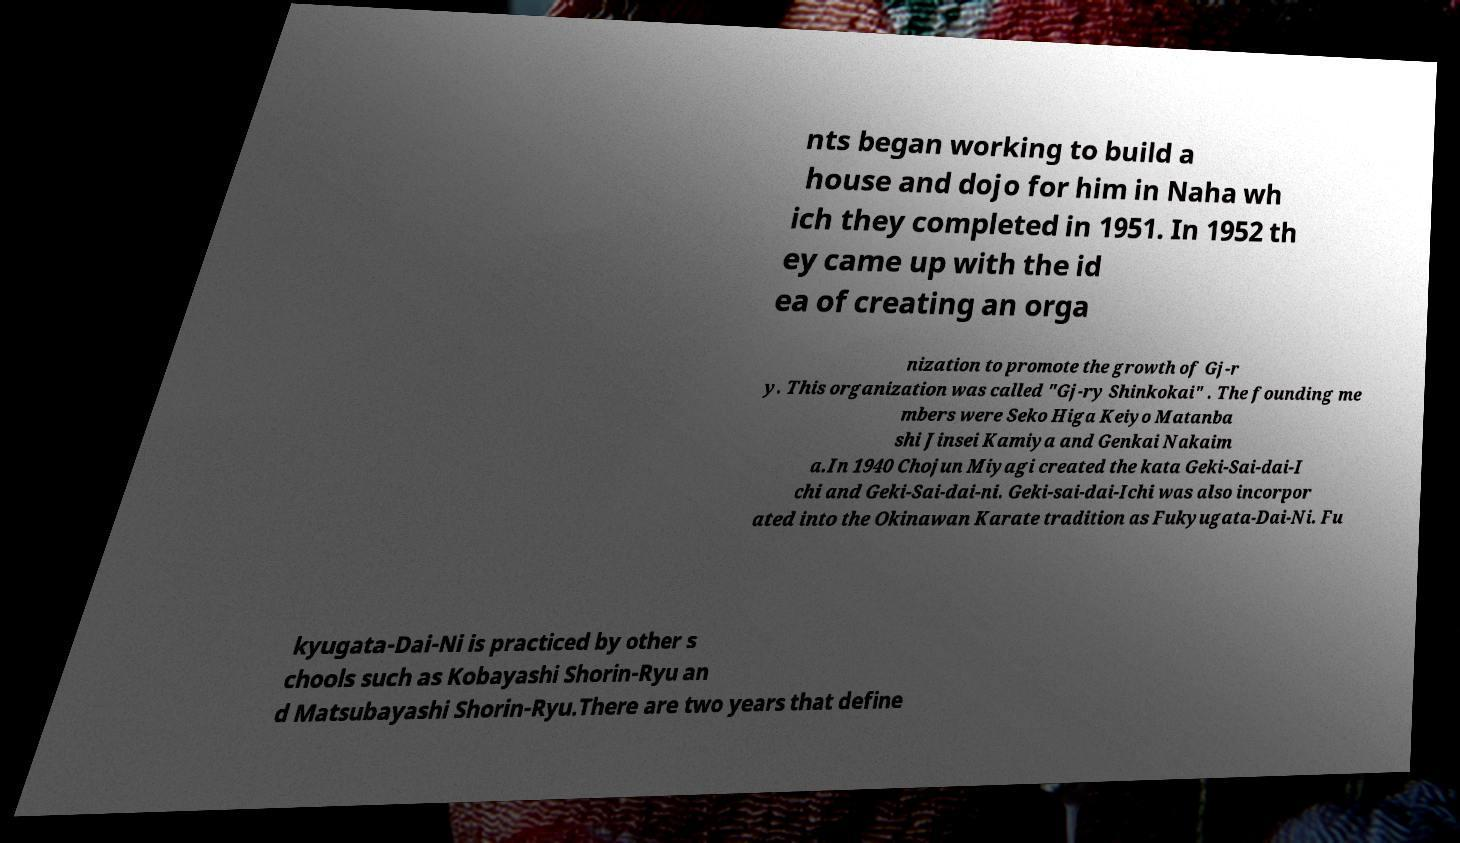Can you read and provide the text displayed in the image?This photo seems to have some interesting text. Can you extract and type it out for me? nts began working to build a house and dojo for him in Naha wh ich they completed in 1951. In 1952 th ey came up with the id ea of creating an orga nization to promote the growth of Gj-r y. This organization was called "Gj-ry Shinkokai" . The founding me mbers were Seko Higa Keiyo Matanba shi Jinsei Kamiya and Genkai Nakaim a.In 1940 Chojun Miyagi created the kata Geki-Sai-dai-I chi and Geki-Sai-dai-ni. Geki-sai-dai-Ichi was also incorpor ated into the Okinawan Karate tradition as Fukyugata-Dai-Ni. Fu kyugata-Dai-Ni is practiced by other s chools such as Kobayashi Shorin-Ryu an d Matsubayashi Shorin-Ryu.There are two years that define 